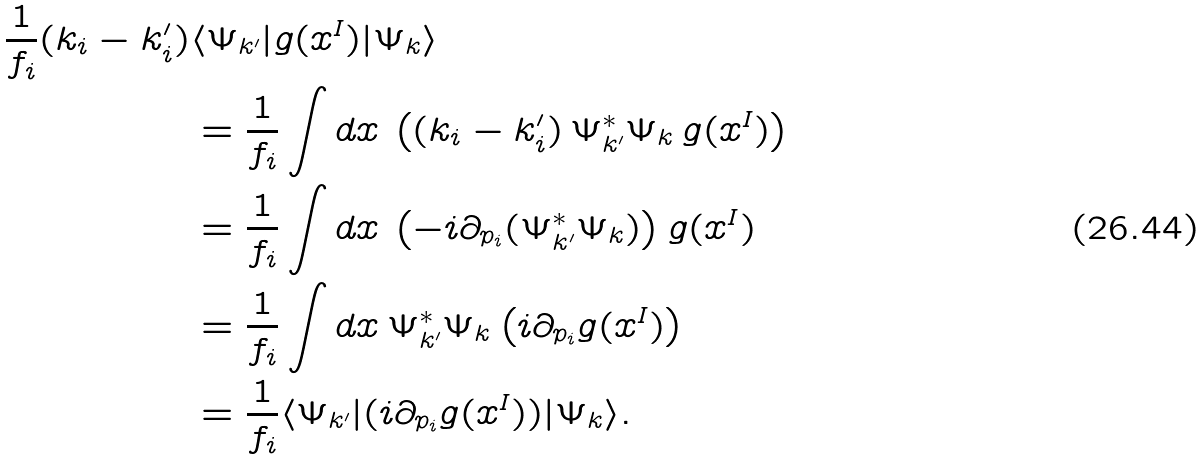<formula> <loc_0><loc_0><loc_500><loc_500>\frac { 1 } { f _ { i } } ( k _ { i } - k ^ { \prime } _ { i } ) & \langle \Psi _ { k ^ { \prime } } | g ( x ^ { I } ) | \Psi _ { k } \rangle \\ & = \frac { 1 } { f _ { i } } \int d x \, \left ( ( k _ { i } - k ^ { \prime } _ { i } ) \, \Psi _ { k ^ { \prime } } ^ { * } \Psi _ { k } \, g ( x ^ { I } ) \right ) \\ & = \frac { 1 } { f _ { i } } \int d x \, \left ( - i \partial _ { p _ { i } } ( \Psi _ { k ^ { \prime } } ^ { * } \Psi _ { k } ) \right ) g ( x ^ { I } ) \\ & = \frac { 1 } { f _ { i } } \int d x \, \Psi _ { k ^ { \prime } } ^ { * } \Psi _ { k } \left ( i \partial _ { p _ { i } } g ( x ^ { I } ) \right ) \\ & = \frac { 1 } { f _ { i } } \langle \Psi _ { k ^ { \prime } } | ( i \partial _ { p _ { i } } g ( x ^ { I } ) ) | \Psi _ { k } \rangle .</formula> 